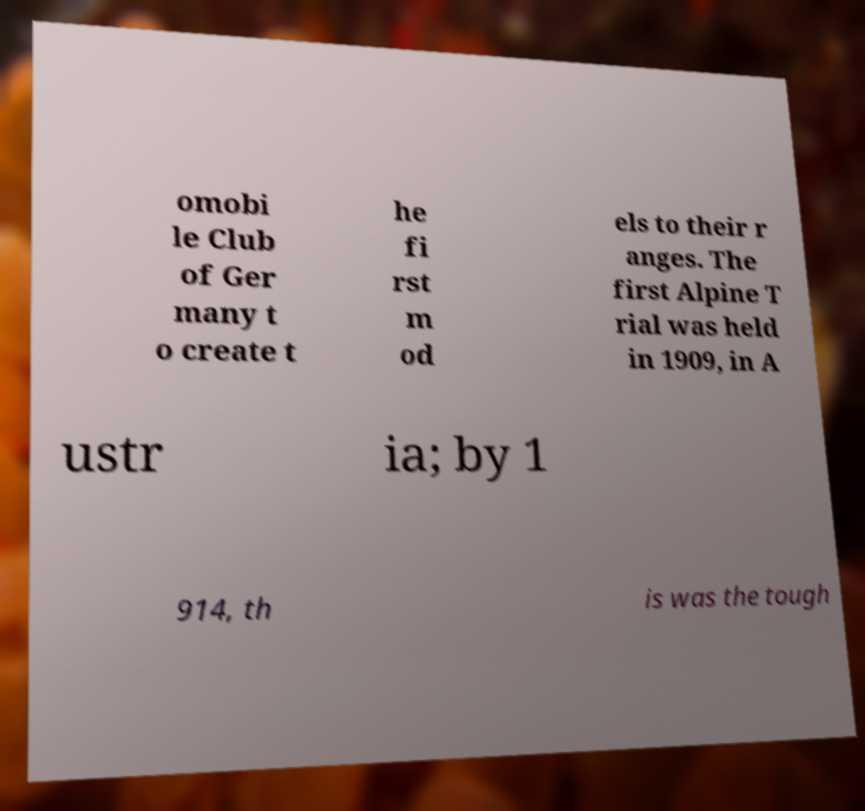I need the written content from this picture converted into text. Can you do that? omobi le Club of Ger many t o create t he fi rst m od els to their r anges. The first Alpine T rial was held in 1909, in A ustr ia; by 1 914, th is was the tough 